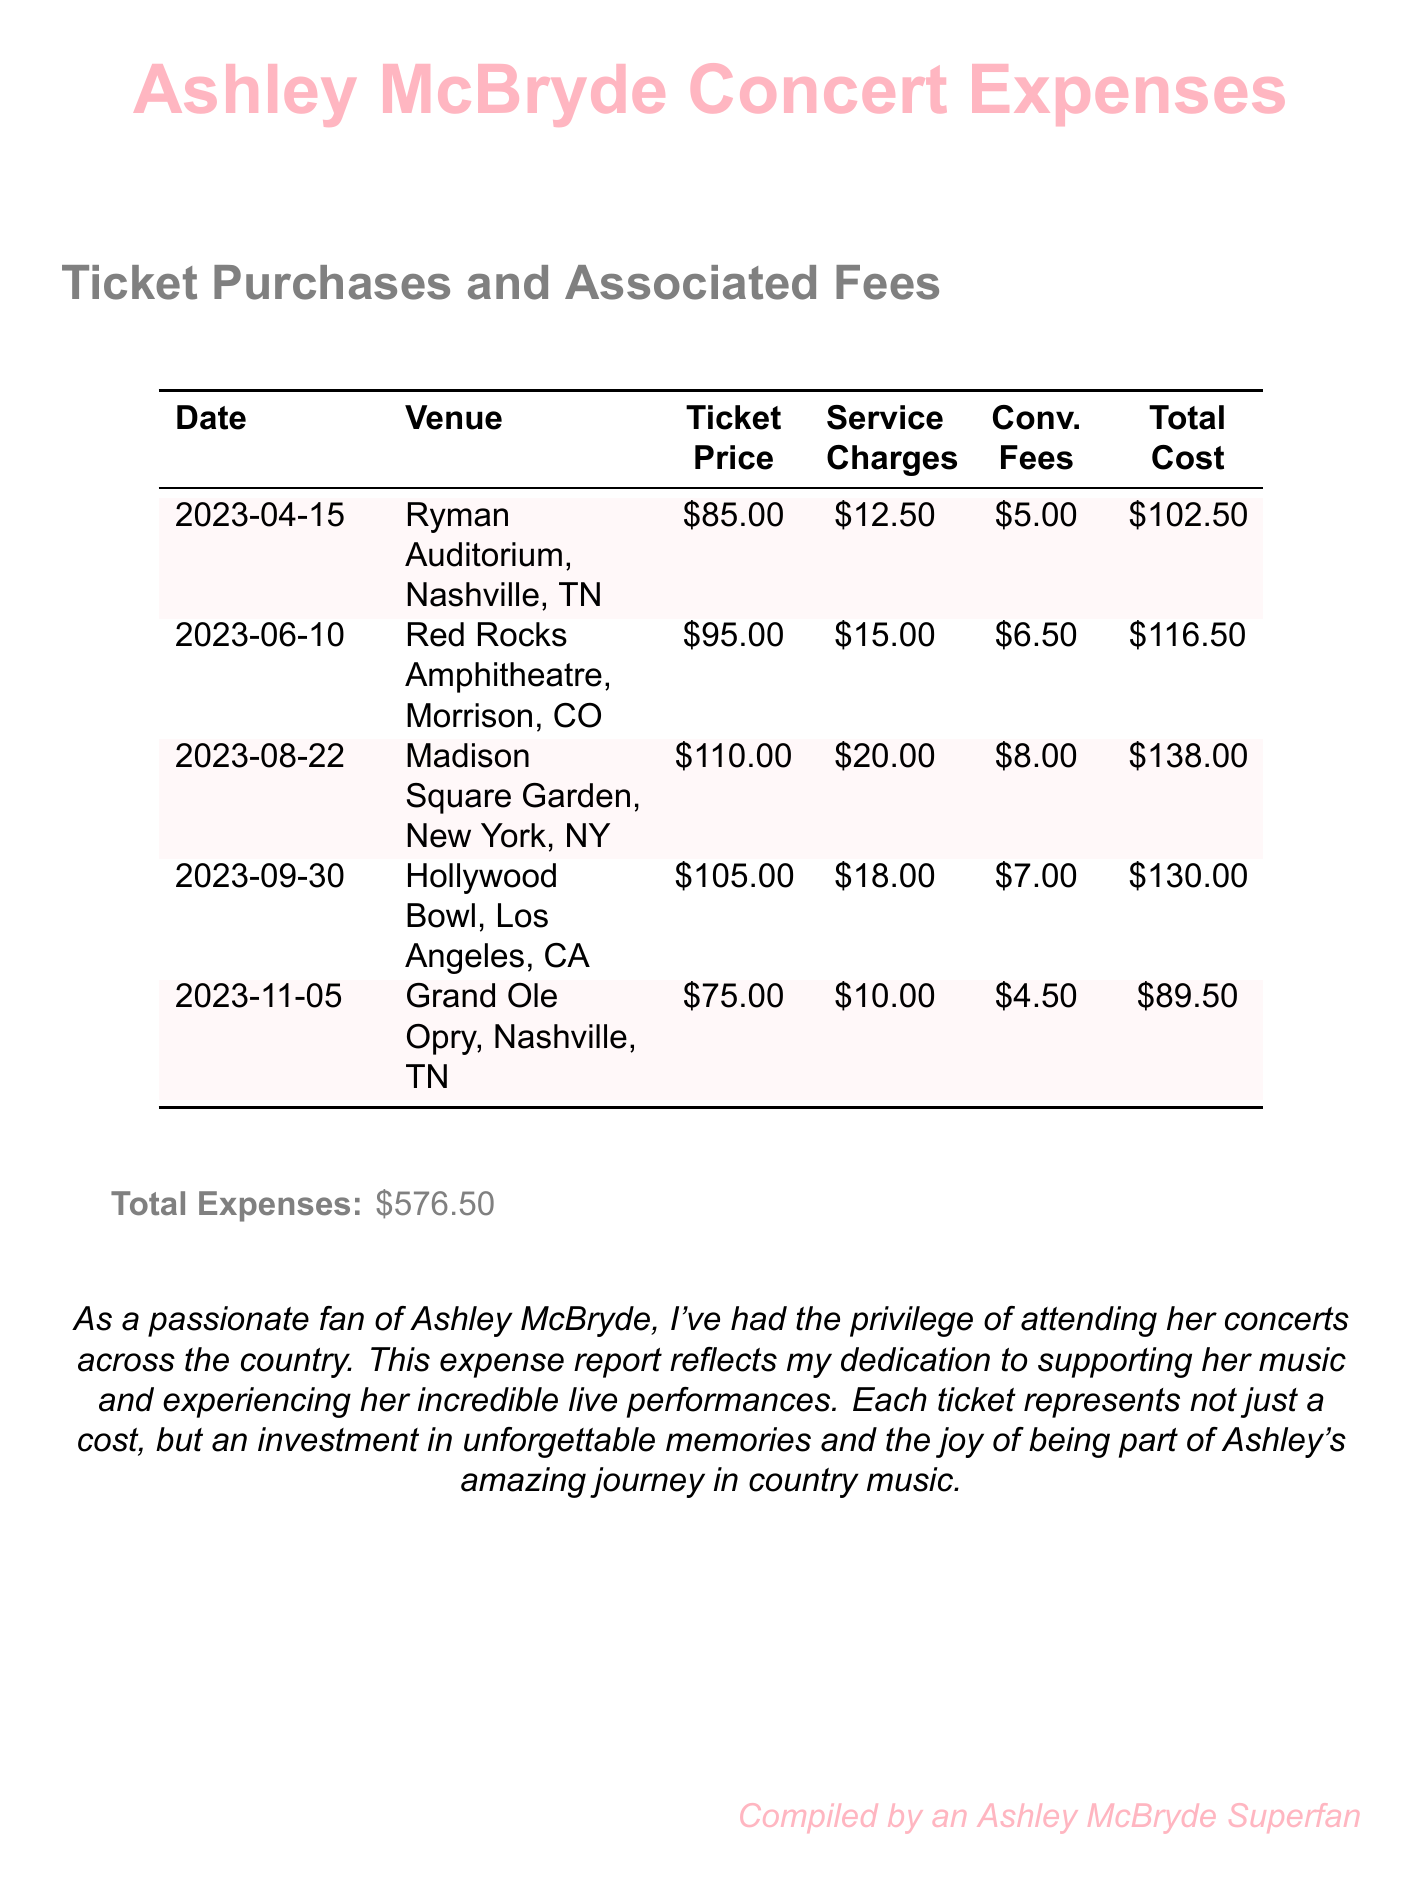What is the total expense for attending concerts? The total expense is listed at the bottom of the table and includes all ticket purchases and associated fees, which is \$576.50.
Answer: \$576.50 How much was the ticket for Madison Square Garden? The ticket price for Madison Square Garden is shown in the table under the Ticket Price column for the specific event, which is \$110.00.
Answer: \$110.00 Which venue had the highest ticket price? By comparing the ticket prices in the table, Madison Square Garden has the highest ticket price of \$110.00 among the listed venues.
Answer: Madison Square Garden What is the service charge for the concert at Red Rocks Amphitheatre? The service charge is found in the table next to the Red Rocks Amphitheatre event, which is \$15.00.
Answer: \$15.00 When did the concert at Hollywood Bowl take place? The date for the Hollywood Bowl concert is provided in the table, which is 2023-09-30.
Answer: 2023-09-30 What convenience fee was charged for the Grand Ole Opry ticket? The convenience fee is specified in the table for the Grand Ole Opry, listed as \$4.50.
Answer: \$4.50 How many concerts are listed in the expense report? The number of concerts can be counted from the rows of the table under the Date column, which shows a total of 5 events.
Answer: 5 What was the total service charge across all events? To find the total service charge, add all service charges listed in the table, which equals \$12.50 + \$15.00 + \$20.00 + \$18.00 + \$10.00 = \$75.50.
Answer: \$75.50 